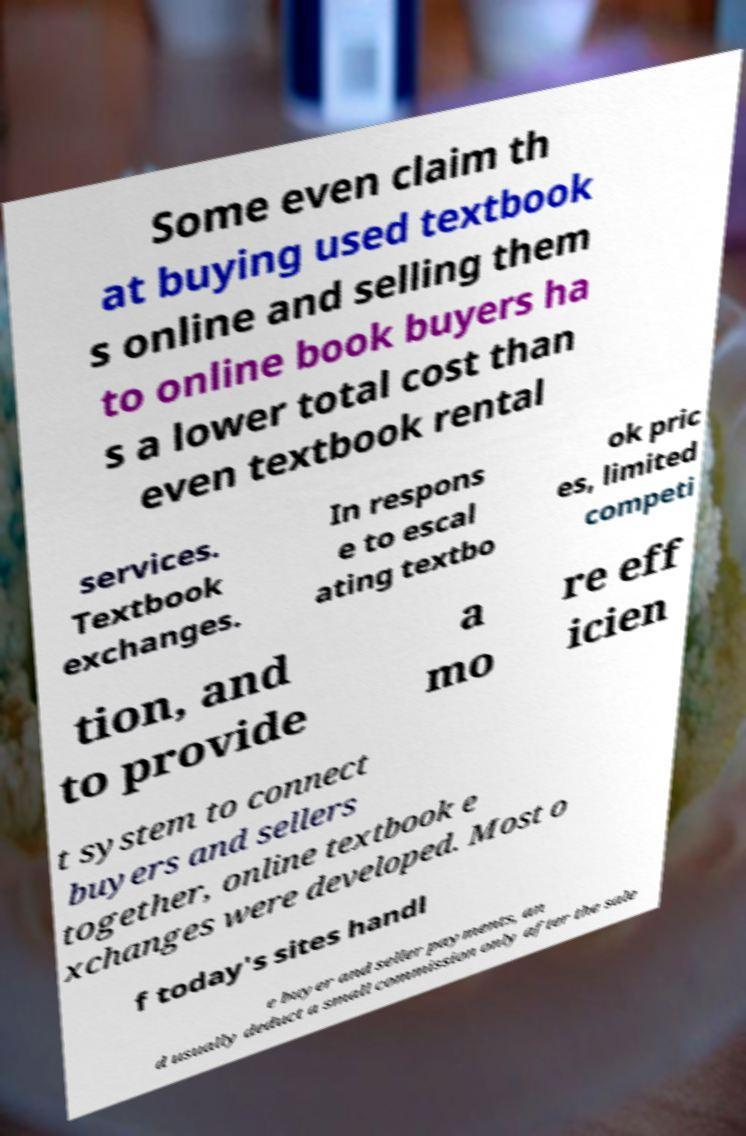Please read and relay the text visible in this image. What does it say? Some even claim th at buying used textbook s online and selling them to online book buyers ha s a lower total cost than even textbook rental services. Textbook exchanges. In respons e to escal ating textbo ok pric es, limited competi tion, and to provide a mo re eff icien t system to connect buyers and sellers together, online textbook e xchanges were developed. Most o f today's sites handl e buyer and seller payments, an d usually deduct a small commission only after the sale 